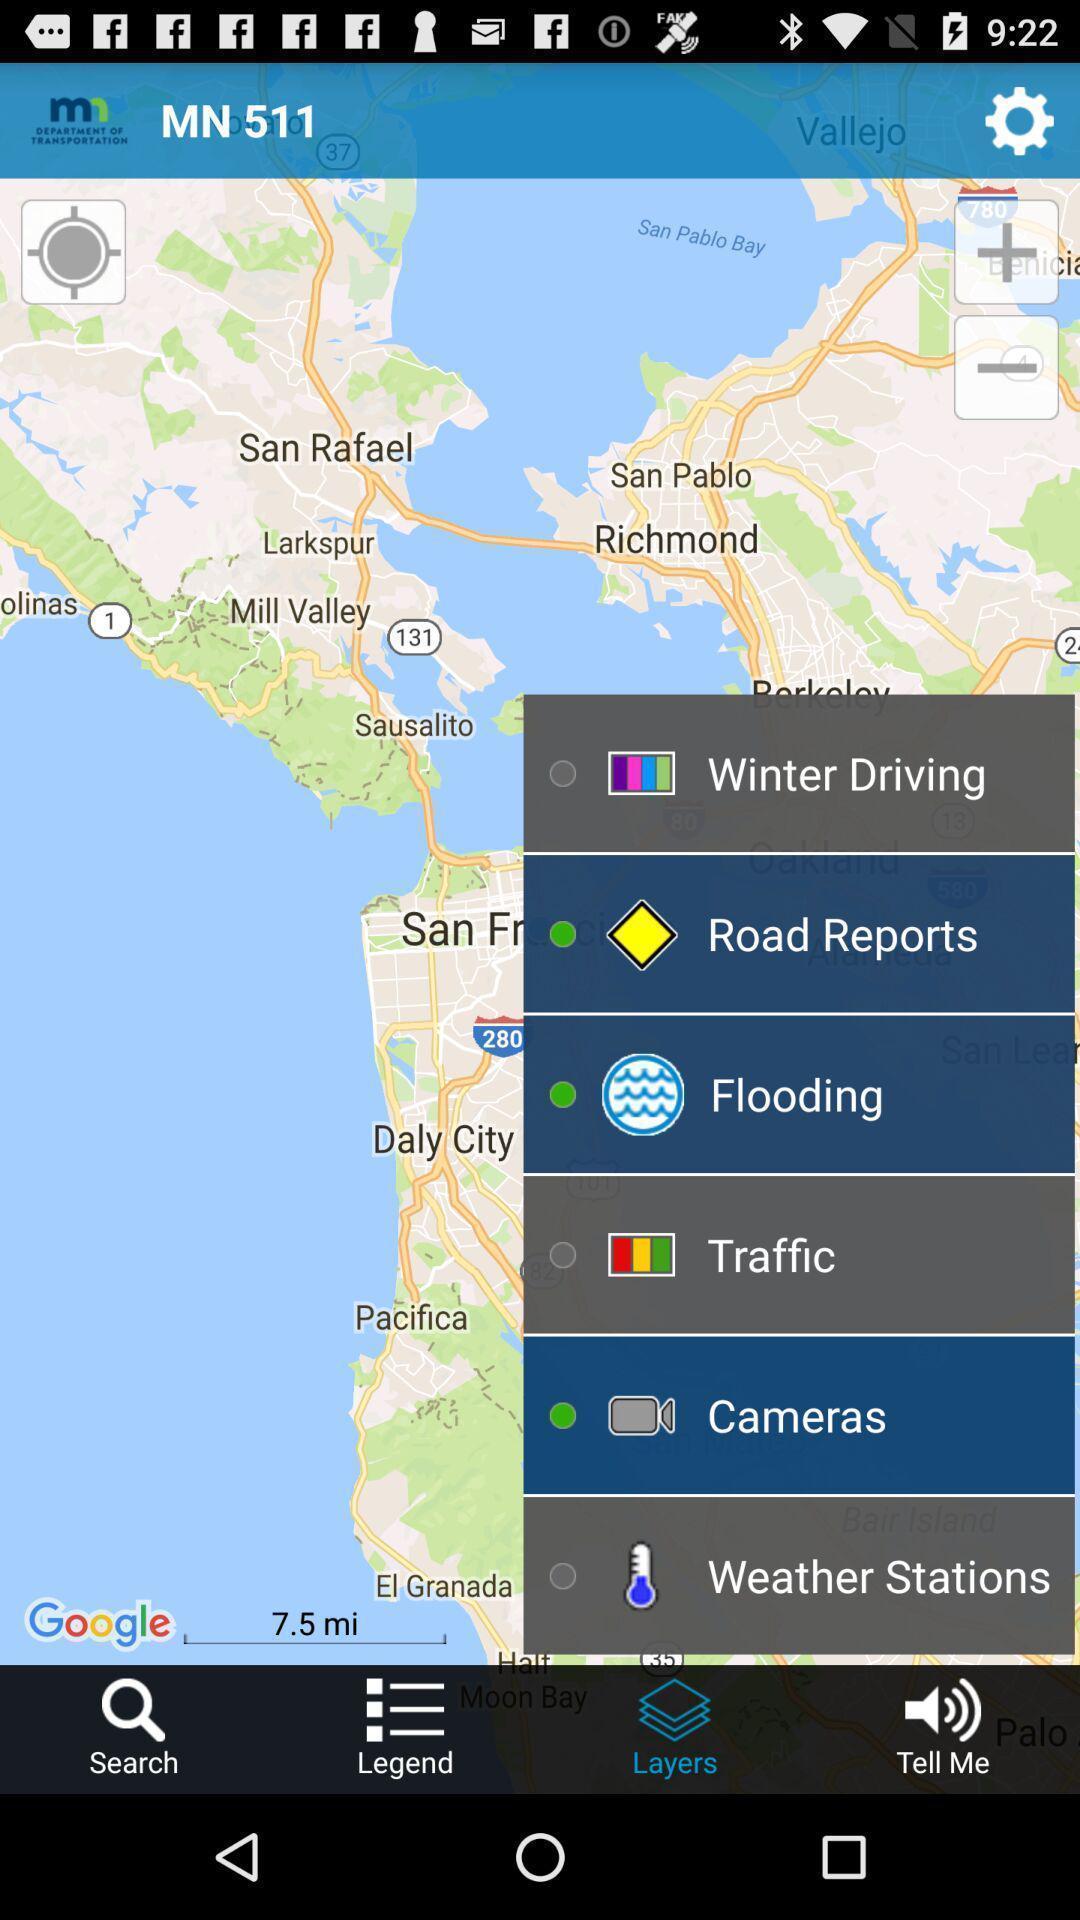Describe the key features of this screenshot. Travel information of a transportation app. 